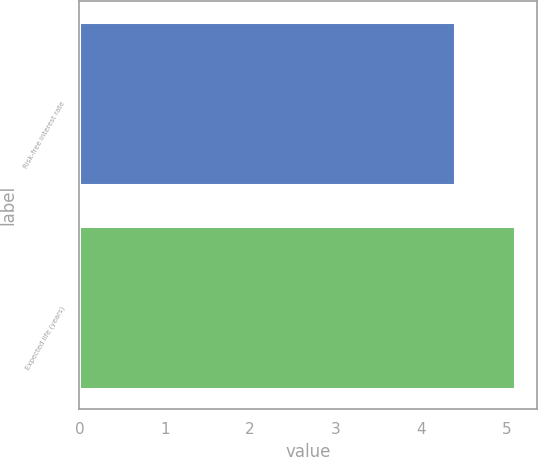<chart> <loc_0><loc_0><loc_500><loc_500><bar_chart><fcel>Risk-free interest rate<fcel>Expected life (years)<nl><fcel>4.4<fcel>5.1<nl></chart> 